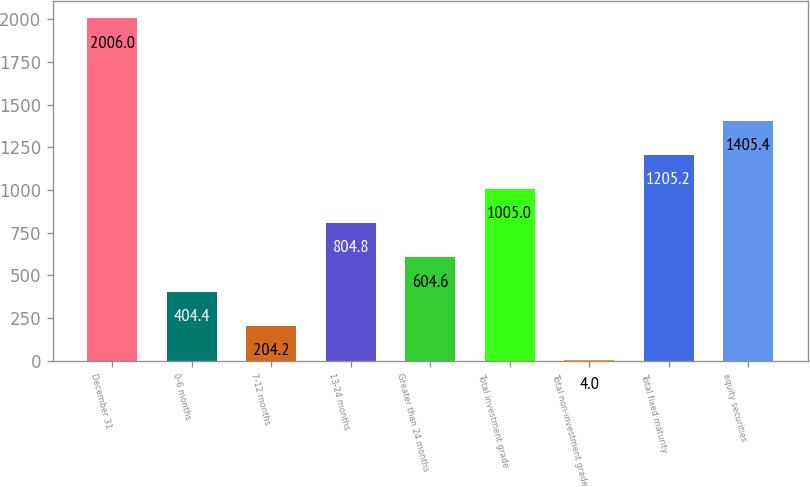Convert chart. <chart><loc_0><loc_0><loc_500><loc_500><bar_chart><fcel>December 31<fcel>0-6 months<fcel>7-12 months<fcel>13-24 months<fcel>Greater than 24 months<fcel>Total investment grade<fcel>Total non-investment grade<fcel>Total fixed maturity<fcel>equity securities<nl><fcel>2006<fcel>404.4<fcel>204.2<fcel>804.8<fcel>604.6<fcel>1005<fcel>4<fcel>1205.2<fcel>1405.4<nl></chart> 